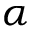<formula> <loc_0><loc_0><loc_500><loc_500>\alpha</formula> 